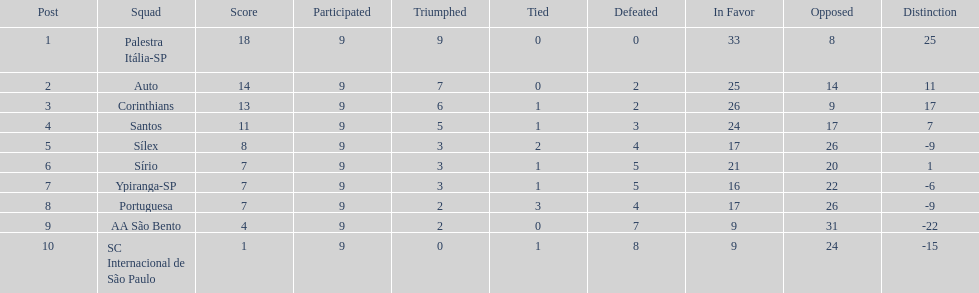Which brazilian team took the top spot in the 1926 brazilian football cup? Palestra Itália-SP. Write the full table. {'header': ['Post', 'Squad', 'Score', 'Participated', 'Triumphed', 'Tied', 'Defeated', 'In Favor', 'Opposed', 'Distinction'], 'rows': [['1', 'Palestra Itália-SP', '18', '9', '9', '0', '0', '33', '8', '25'], ['2', 'Auto', '14', '9', '7', '0', '2', '25', '14', '11'], ['3', 'Corinthians', '13', '9', '6', '1', '2', '26', '9', '17'], ['4', 'Santos', '11', '9', '5', '1', '3', '24', '17', '7'], ['5', 'Sílex', '8', '9', '3', '2', '4', '17', '26', '-9'], ['6', 'Sírio', '7', '9', '3', '1', '5', '21', '20', '1'], ['7', 'Ypiranga-SP', '7', '9', '3', '1', '5', '16', '22', '-6'], ['8', 'Portuguesa', '7', '9', '2', '3', '4', '17', '26', '-9'], ['9', 'AA São Bento', '4', '9', '2', '0', '7', '9', '31', '-22'], ['10', 'SC Internacional de São Paulo', '1', '9', '0', '1', '8', '9', '24', '-15']]} 